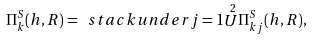<formula> <loc_0><loc_0><loc_500><loc_500>\Pi _ { k } ^ { S } ( h , R ) = \ s t a c k u n d e r { j = 1 } { \stackrel { 2 } { U } } \Pi _ { k j } ^ { S } ( h , R ) ,</formula> 